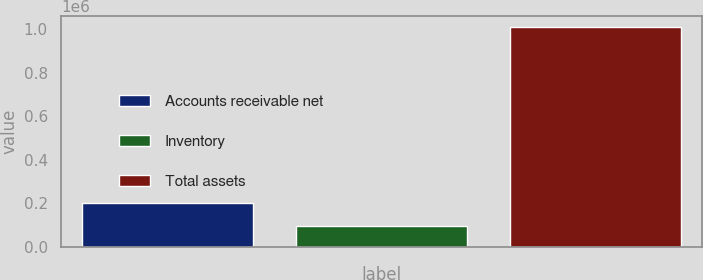Convert chart to OTSL. <chart><loc_0><loc_0><loc_500><loc_500><bar_chart><fcel>Accounts receivable net<fcel>Inventory<fcel>Total assets<nl><fcel>199395<fcel>93996<fcel>1.00857e+06<nl></chart> 